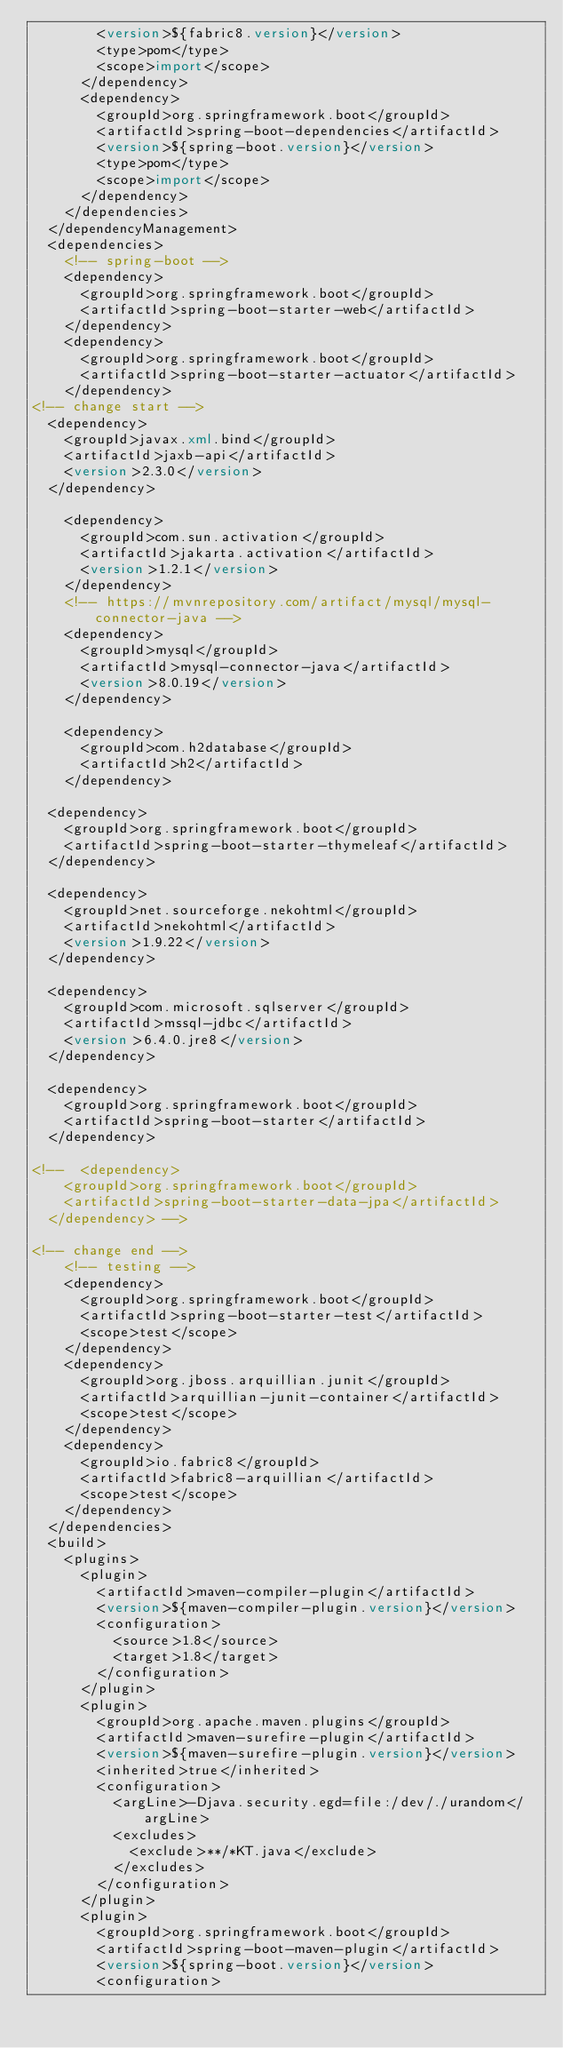<code> <loc_0><loc_0><loc_500><loc_500><_XML_>        <version>${fabric8.version}</version>
        <type>pom</type>
        <scope>import</scope>
      </dependency>
      <dependency>
        <groupId>org.springframework.boot</groupId>
        <artifactId>spring-boot-dependencies</artifactId>
        <version>${spring-boot.version}</version>
        <type>pom</type>
        <scope>import</scope>
      </dependency>
    </dependencies>
  </dependencyManagement>
  <dependencies>
    <!-- spring-boot -->
    <dependency>
      <groupId>org.springframework.boot</groupId>
      <artifactId>spring-boot-starter-web</artifactId>
    </dependency>
    <dependency>
      <groupId>org.springframework.boot</groupId>
      <artifactId>spring-boot-starter-actuator</artifactId>
    </dependency>
<!-- change start -->
	<dependency>
		<groupId>javax.xml.bind</groupId>
		<artifactId>jaxb-api</artifactId>
		<version>2.3.0</version>
	</dependency>

		<dependency>
			<groupId>com.sun.activation</groupId>
			<artifactId>jakarta.activation</artifactId>
			<version>1.2.1</version>
		</dependency>
		<!-- https://mvnrepository.com/artifact/mysql/mysql-connector-java -->
		<dependency>
			<groupId>mysql</groupId>
			<artifactId>mysql-connector-java</artifactId>
			<version>8.0.19</version>
		</dependency>

		<dependency>
			<groupId>com.h2database</groupId>
			<artifactId>h2</artifactId>
		</dependency>

	<dependency>
		<groupId>org.springframework.boot</groupId>
		<artifactId>spring-boot-starter-thymeleaf</artifactId>
	</dependency>

	<dependency>
		<groupId>net.sourceforge.nekohtml</groupId>
		<artifactId>nekohtml</artifactId>
		<version>1.9.22</version>
	</dependency>

	<dependency>
		<groupId>com.microsoft.sqlserver</groupId>
		<artifactId>mssql-jdbc</artifactId>
		<version>6.4.0.jre8</version>
	</dependency>

	<dependency>
		<groupId>org.springframework.boot</groupId>
		<artifactId>spring-boot-starter</artifactId>
	</dependency>

<!-- 	<dependency>
		<groupId>org.springframework.boot</groupId>
		<artifactId>spring-boot-starter-data-jpa</artifactId>
	</dependency> -->
	
<!-- change end -->
    <!-- testing -->
    <dependency>
      <groupId>org.springframework.boot</groupId>
      <artifactId>spring-boot-starter-test</artifactId>
      <scope>test</scope>
    </dependency>
    <dependency>
      <groupId>org.jboss.arquillian.junit</groupId>
      <artifactId>arquillian-junit-container</artifactId>
      <scope>test</scope>
    </dependency>
    <dependency>
      <groupId>io.fabric8</groupId>
      <artifactId>fabric8-arquillian</artifactId>
      <scope>test</scope>
    </dependency>
  </dependencies>
  <build>
    <plugins>
      <plugin>
        <artifactId>maven-compiler-plugin</artifactId>
        <version>${maven-compiler-plugin.version}</version>
        <configuration>
          <source>1.8</source>
          <target>1.8</target>
        </configuration>
      </plugin>
      <plugin>
        <groupId>org.apache.maven.plugins</groupId>
        <artifactId>maven-surefire-plugin</artifactId>
        <version>${maven-surefire-plugin.version}</version>
        <inherited>true</inherited>
        <configuration>
          <argLine>-Djava.security.egd=file:/dev/./urandom</argLine>
          <excludes>
            <exclude>**/*KT.java</exclude>
          </excludes>
        </configuration>
      </plugin>
      <plugin>
        <groupId>org.springframework.boot</groupId>
        <artifactId>spring-boot-maven-plugin</artifactId>
        <version>${spring-boot.version}</version>
        <configuration></code> 